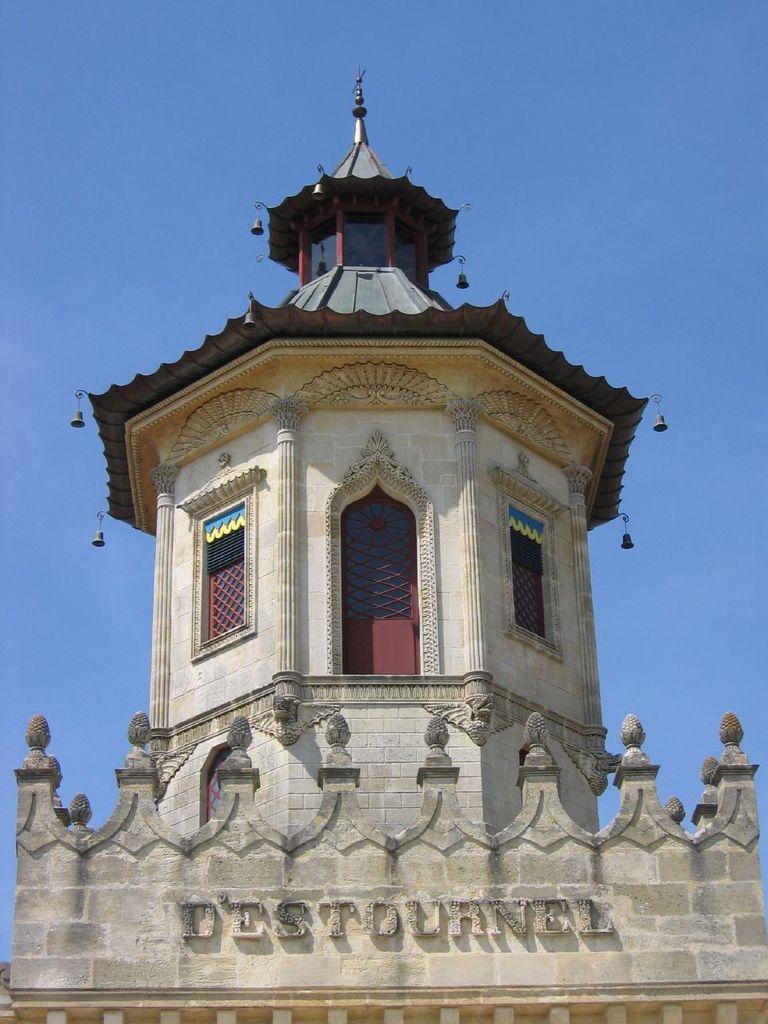What is the main subject of the image? There is a monument in the image. What can be seen on the monument? There is text on the wall of the monument. What is the color of the sky in the image? The sky is blue in the image. How does the monument rub against the wire in the image? There is no wire present in the image, so the monument cannot rub against it. 